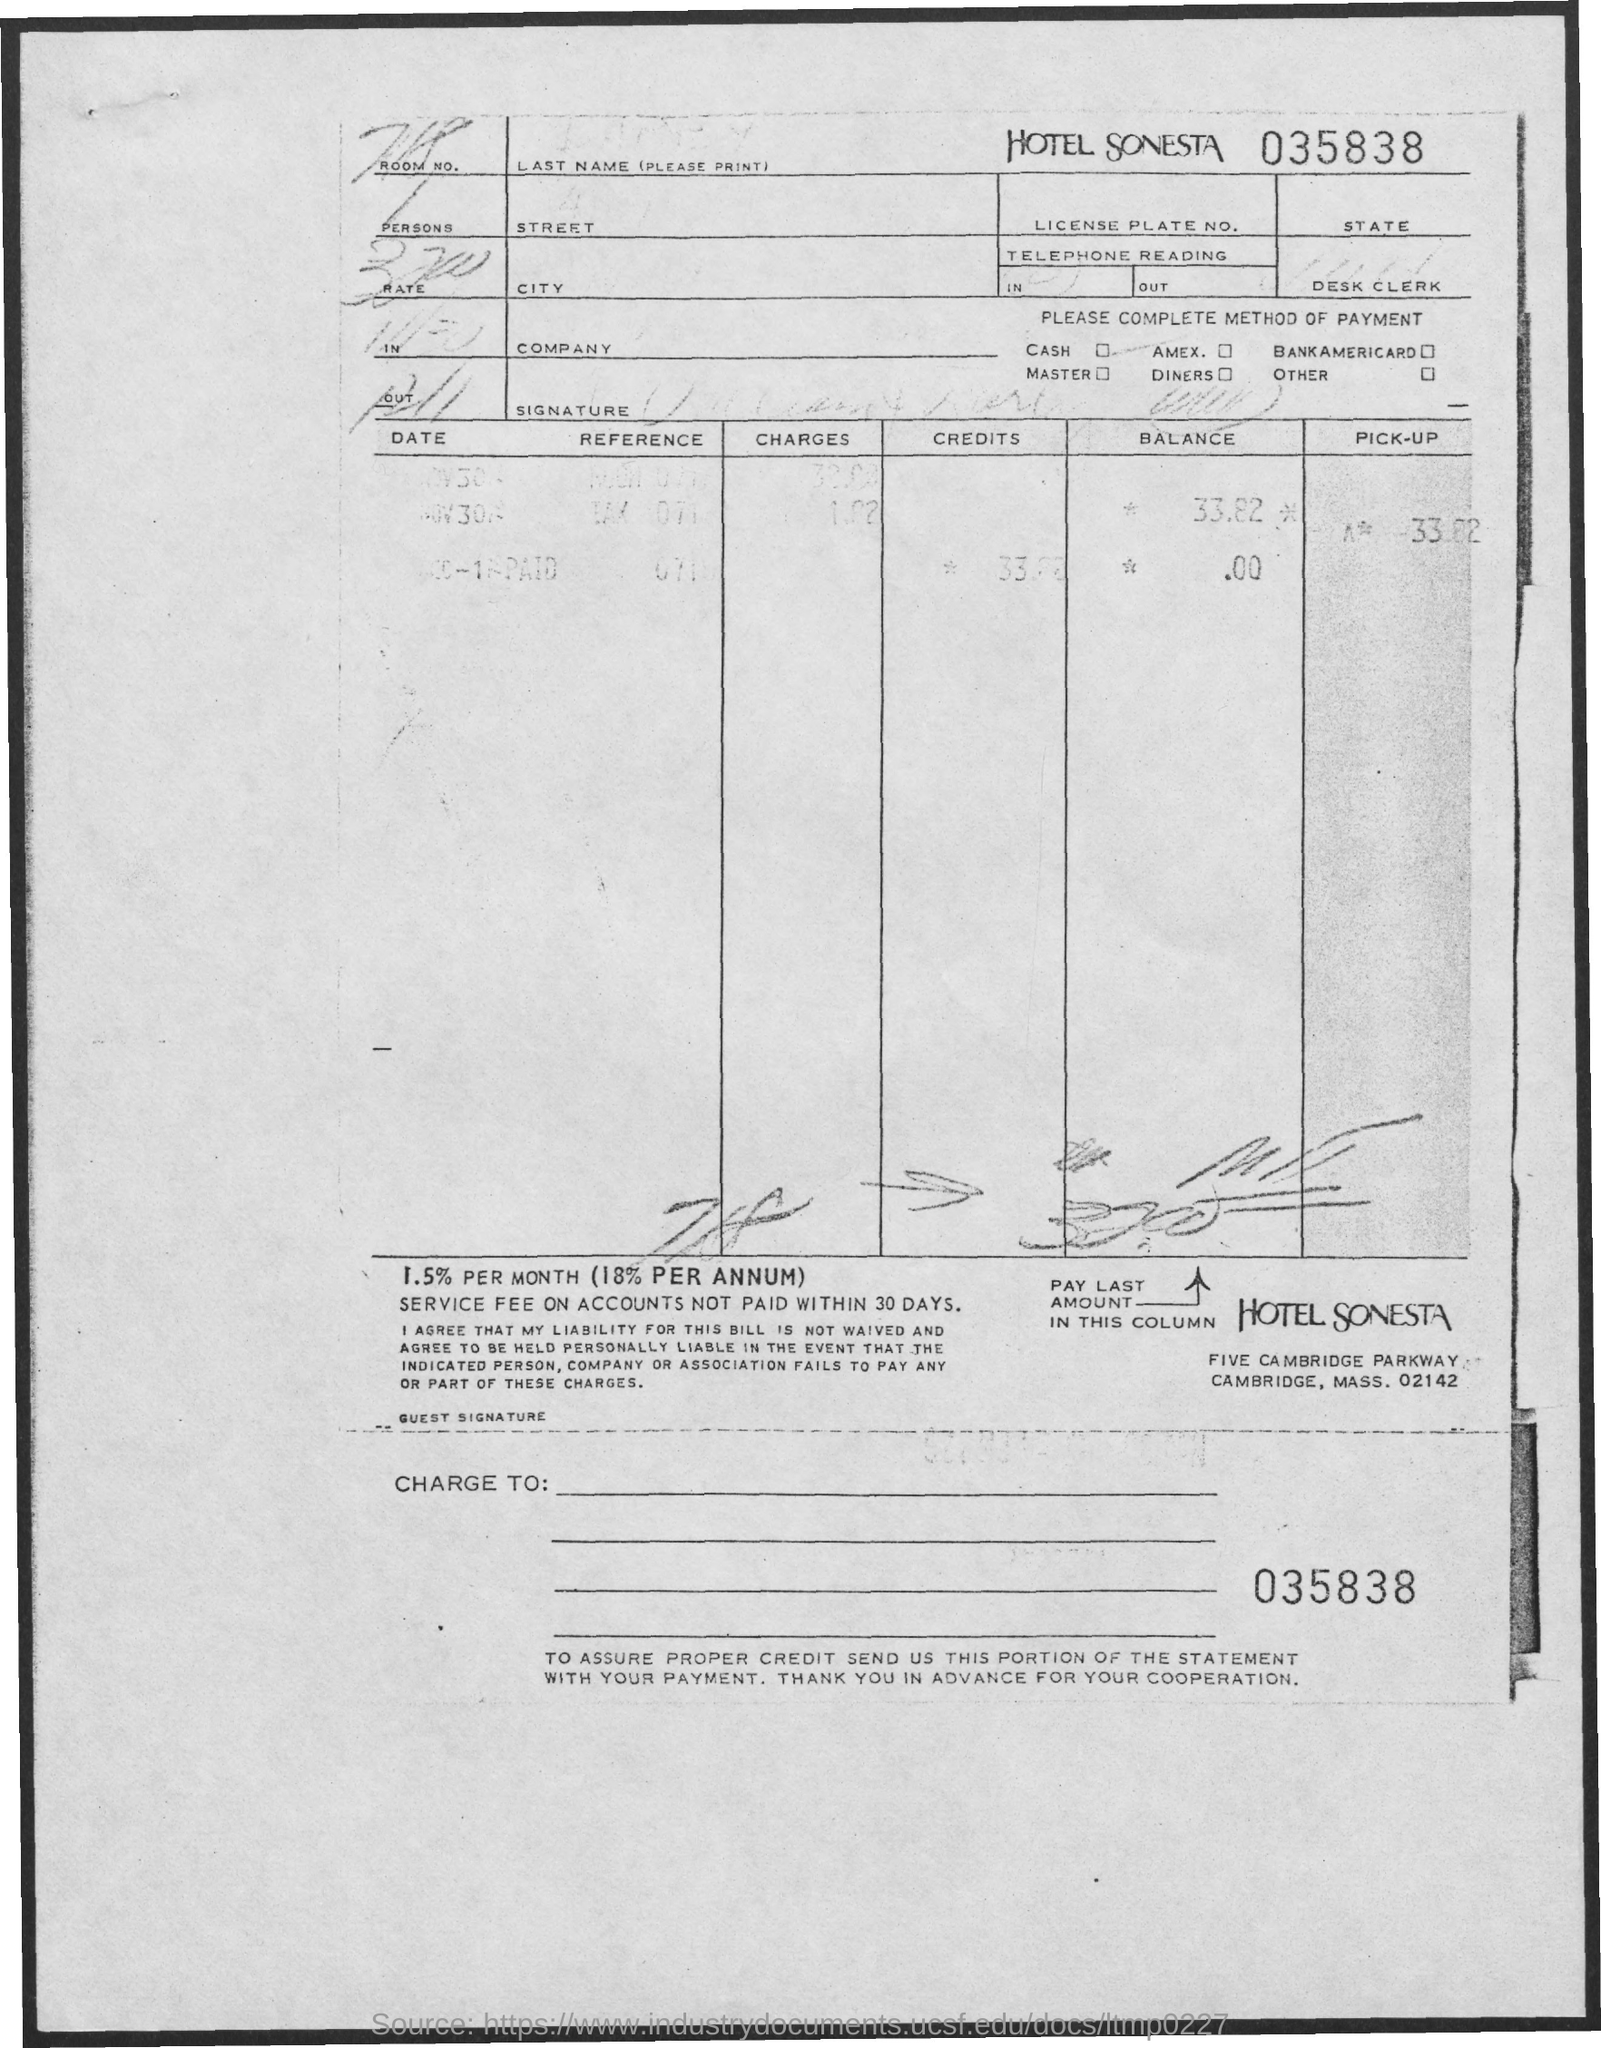Which hotel is mentioned?
Provide a succinct answer. HOTEL SONESTA. 